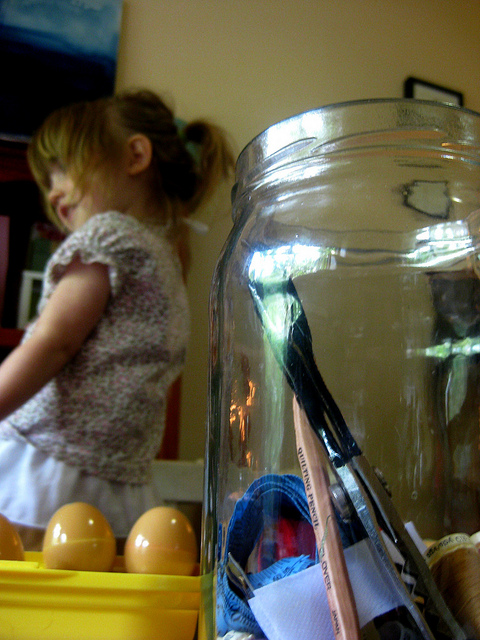What activity might be taking place here given the objects present? Based on the items in the image, it appears to be an environment for creative activities or a learning setting, such as a classroom or a home play area. Are there any objects that suggest a particular time of day or season? Nothing in the image definitively indicates the time of day or season, but the bright indoor lighting and the casual setting might suggest daytime indoor activities. 